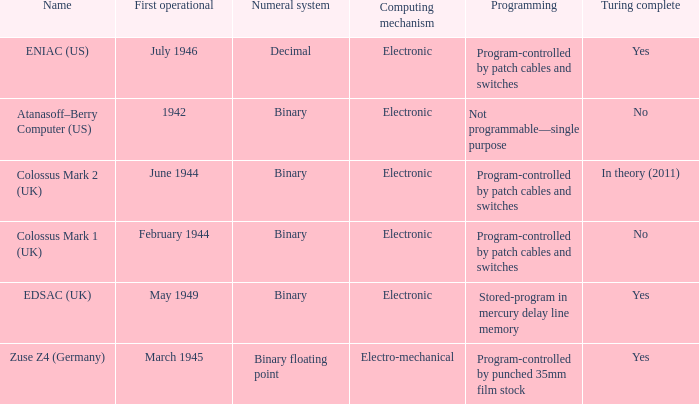What's the turing complete with numeral system being decimal Yes. 